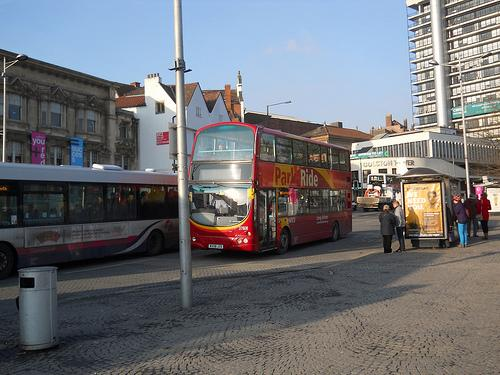Briefly explain how the objects and subjects in the image are interacting with each other. The pedestrians are waiting at the bus stop to board the red double-decker bus, while the bus is parked beside the sidewalk allowing passengers to exit or enter. Count the number of people in the image and determine their action. There are 6 people standing by the bus stop and 1 person on the top level of the bus, so a total of 7 people. Describe the emotions or feelings that the image evokes. The image evokes a sense of urban life, public transportation, and busy streets with people going about their daily routine. Assess the image quality based on the clarity of the objects within the picture. The image quality is good, with clear details visible for the bus, bus stop, buildings, and other objects. What is the primary mode of transportation in the image and describe its appearance. The primary mode of transportation is a red double-decker bus with passengers both standing inside and sitting on the top level. Describe the scene in the image, including the weather and time of day. The scene is a city street with a double-decker bus, buildings, and pedestrians waiting at a bus stop. The weather appears to be clear and sunny, with white clouds in the blue sky. Find the green bicycle parked in front of the double-decker bus. There is no mention of a green bicycle in the image details. Asking someone to find it would lead to confusion since such an object doesn't exist. Notice the flock of birds flying above the double-decker bus. There are no birds mentioned in the image details. Instructing someone to notice a flock of birds that doesn't exist would be misguiding. Can you find the group of children playing soccer near the bus stop? The image details do not mention any children playing soccer. By asking someone to find a group of children playing soccer, we would be providing a misleading instruction. Examine the large graffiti art on the side of the apartment building. The image details do not mention any graffiti art on any building. By asking someone to examine a non-existent graffiti art, we would be providing a misleading instruction. Can you locate the pink unicorn standing near the bus stop? There is no mention of a pink unicorn in the provided information, so it would be misleading to ask someone to locate it. What is the make and model of the sports car parked near the garbage can on the sidewalk? There is no sports car mentioned in the image details. Asking a question involving a non-existent object would create confusion and mislead the person trying to understand the image. 